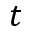Convert formula to latex. <formula><loc_0><loc_0><loc_500><loc_500>t</formula> 